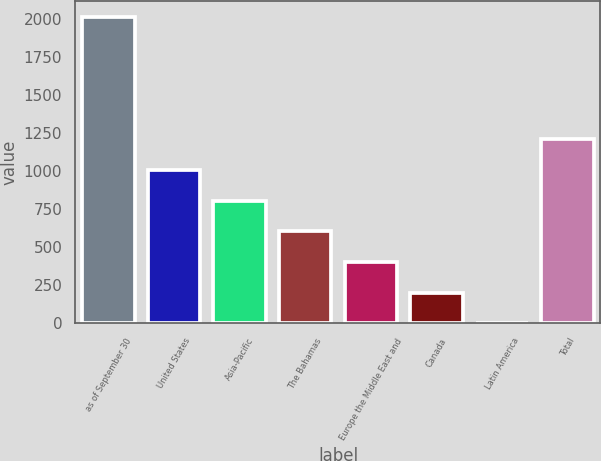<chart> <loc_0><loc_0><loc_500><loc_500><bar_chart><fcel>as of September 30<fcel>United States<fcel>Asia-Pacific<fcel>The Bahamas<fcel>Europe the Middle East and<fcel>Canada<fcel>Latin America<fcel>Total<nl><fcel>2014<fcel>1007.45<fcel>806.14<fcel>604.83<fcel>403.52<fcel>202.21<fcel>0.9<fcel>1208.76<nl></chart> 